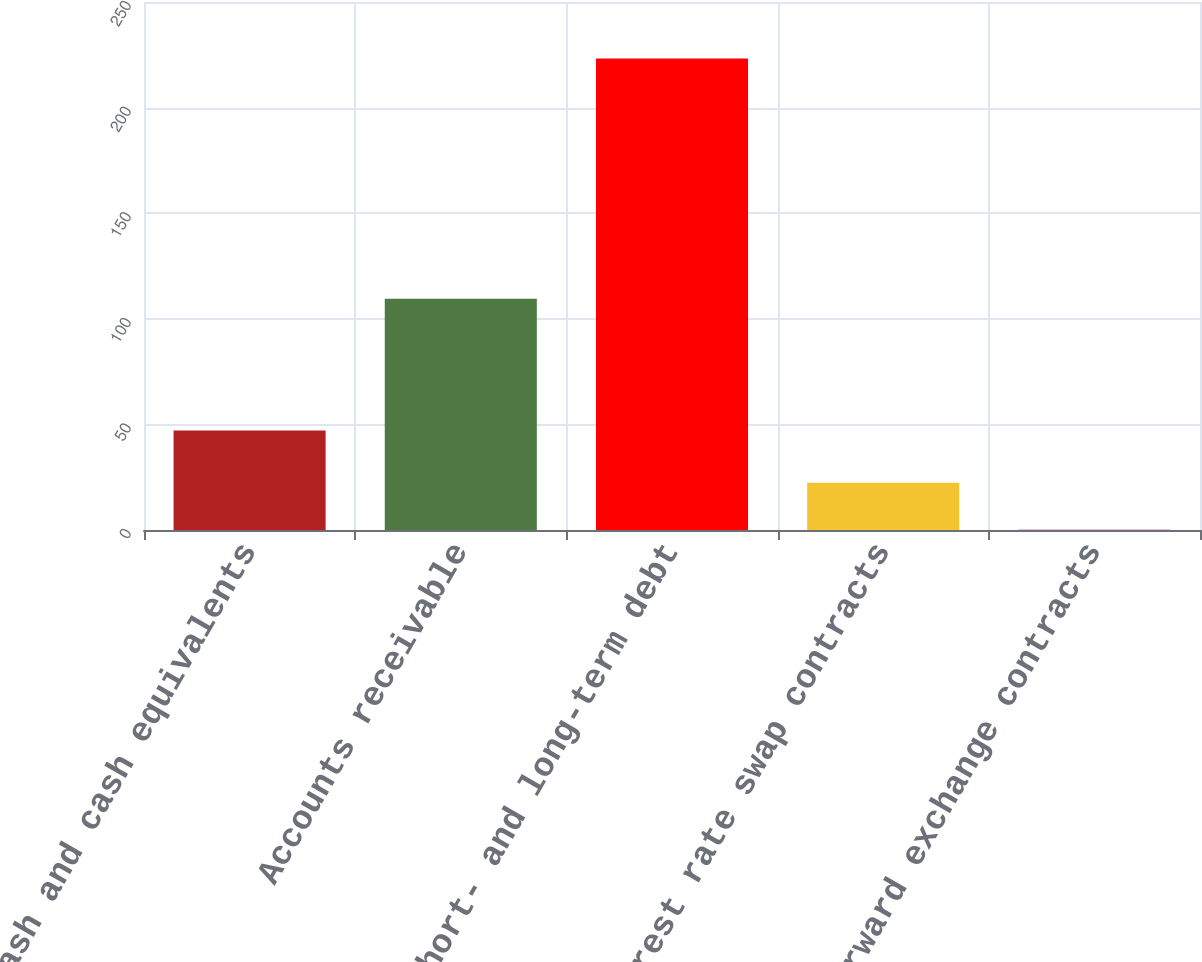<chart> <loc_0><loc_0><loc_500><loc_500><bar_chart><fcel>Cash and cash equivalents<fcel>Accounts receivable<fcel>Short- and long-term debt<fcel>Interest rate swap contracts<fcel>Forward exchange contracts<nl><fcel>47.1<fcel>109.5<fcel>223.2<fcel>22.41<fcel>0.1<nl></chart> 